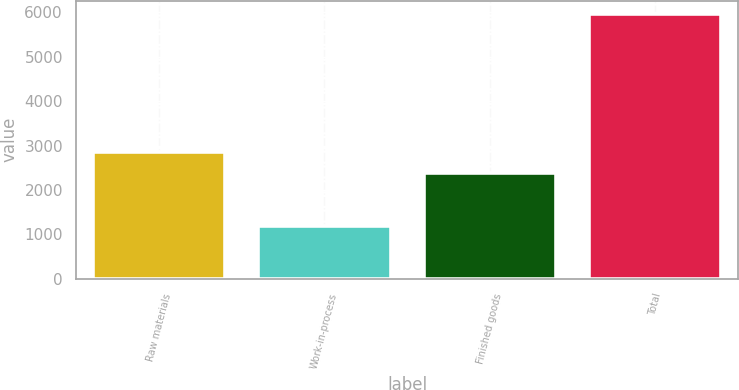Convert chart. <chart><loc_0><loc_0><loc_500><loc_500><bar_chart><fcel>Raw materials<fcel>Work-in-process<fcel>Finished goods<fcel>Total<nl><fcel>2857.3<fcel>1183<fcel>2379<fcel>5966<nl></chart> 